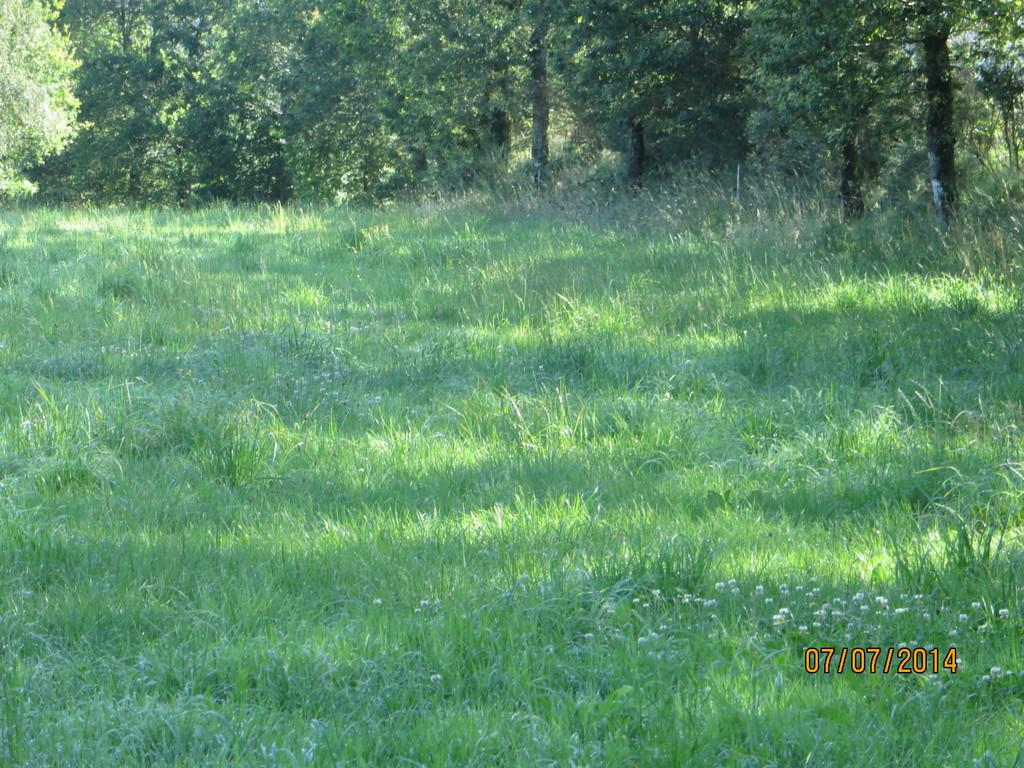What type of ground is visible in the image? There is a greenery ground in the image. What can be seen in the background of the image? There are trees in the background of the image. Where is the text or image located in the image? The text or image is in the right bottom corner of the image. How many airports can be seen in the image? There are no airports present in the image. What type of tools does the carpenter have in the image? There is no carpenter or tools present in the image. 